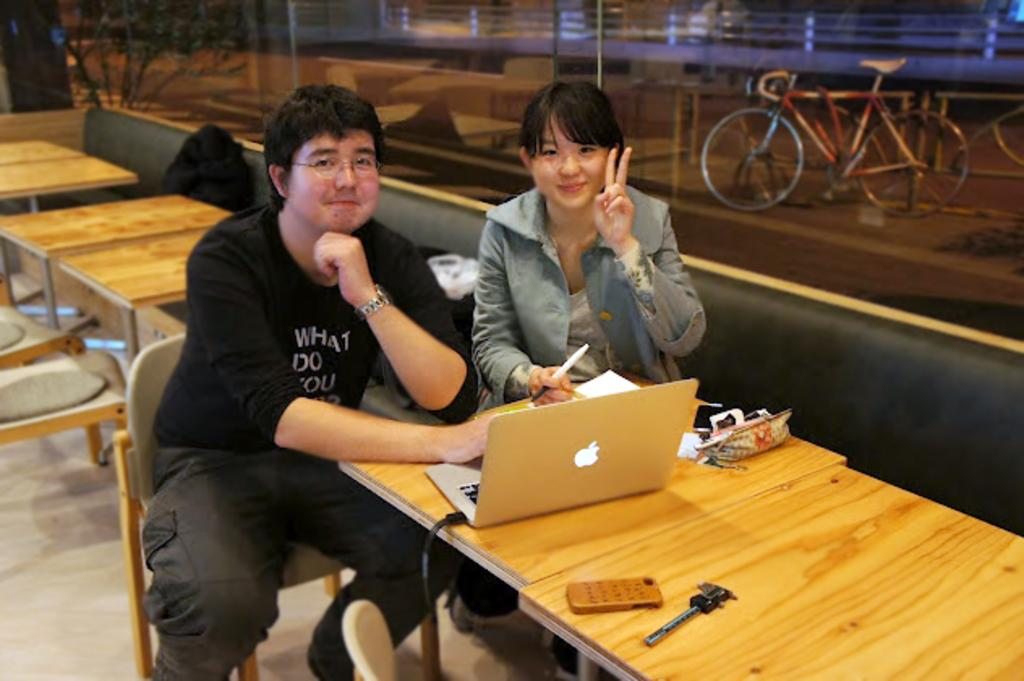How many people are sitting in the front in the image? There are two people sitting in the front on chairs. What can be seen on the table in the image? There is a laptop and a pouch on the table. What is visible in the background of the image? There is a bicycle, buildings, and a tree in the background. What type of calendar is hanging on the tree in the background? There is no calendar present in the image; it only features a tree in the background. 